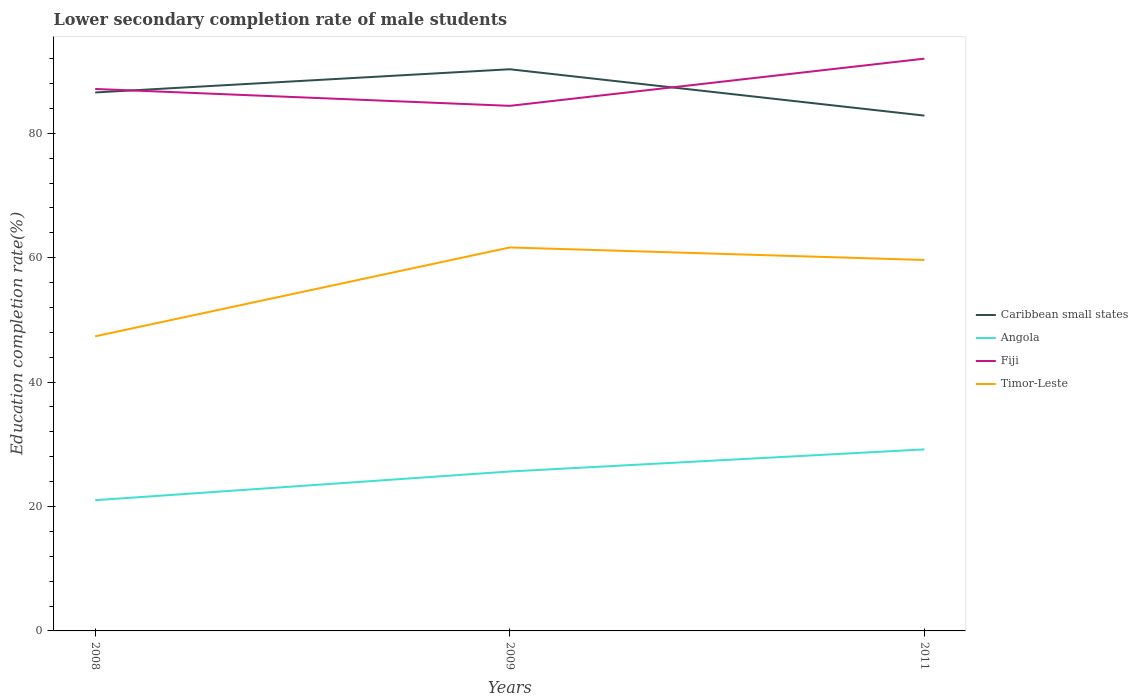How many different coloured lines are there?
Your response must be concise. 4. Does the line corresponding to Angola intersect with the line corresponding to Fiji?
Give a very brief answer. No. Is the number of lines equal to the number of legend labels?
Provide a succinct answer. Yes. Across all years, what is the maximum lower secondary completion rate of male students in Caribbean small states?
Provide a short and direct response. 82.84. What is the total lower secondary completion rate of male students in Fiji in the graph?
Give a very brief answer. 2.71. What is the difference between the highest and the second highest lower secondary completion rate of male students in Fiji?
Your response must be concise. 7.59. How many lines are there?
Keep it short and to the point. 4. What is the difference between two consecutive major ticks on the Y-axis?
Offer a terse response. 20. Does the graph contain any zero values?
Your answer should be compact. No. How are the legend labels stacked?
Ensure brevity in your answer.  Vertical. What is the title of the graph?
Offer a very short reply. Lower secondary completion rate of male students. What is the label or title of the X-axis?
Your response must be concise. Years. What is the label or title of the Y-axis?
Give a very brief answer. Education completion rate(%). What is the Education completion rate(%) in Caribbean small states in 2008?
Offer a very short reply. 86.56. What is the Education completion rate(%) in Angola in 2008?
Your answer should be very brief. 21.01. What is the Education completion rate(%) in Fiji in 2008?
Make the answer very short. 87.12. What is the Education completion rate(%) of Timor-Leste in 2008?
Offer a terse response. 47.36. What is the Education completion rate(%) of Caribbean small states in 2009?
Offer a very short reply. 90.29. What is the Education completion rate(%) in Angola in 2009?
Provide a short and direct response. 25.63. What is the Education completion rate(%) in Fiji in 2009?
Offer a very short reply. 84.41. What is the Education completion rate(%) of Timor-Leste in 2009?
Your answer should be compact. 61.64. What is the Education completion rate(%) of Caribbean small states in 2011?
Your answer should be very brief. 82.84. What is the Education completion rate(%) in Angola in 2011?
Offer a terse response. 29.18. What is the Education completion rate(%) of Fiji in 2011?
Your response must be concise. 92. What is the Education completion rate(%) in Timor-Leste in 2011?
Your response must be concise. 59.63. Across all years, what is the maximum Education completion rate(%) of Caribbean small states?
Your answer should be compact. 90.29. Across all years, what is the maximum Education completion rate(%) in Angola?
Make the answer very short. 29.18. Across all years, what is the maximum Education completion rate(%) of Fiji?
Your answer should be very brief. 92. Across all years, what is the maximum Education completion rate(%) of Timor-Leste?
Your answer should be very brief. 61.64. Across all years, what is the minimum Education completion rate(%) of Caribbean small states?
Offer a terse response. 82.84. Across all years, what is the minimum Education completion rate(%) in Angola?
Give a very brief answer. 21.01. Across all years, what is the minimum Education completion rate(%) of Fiji?
Provide a short and direct response. 84.41. Across all years, what is the minimum Education completion rate(%) of Timor-Leste?
Offer a very short reply. 47.36. What is the total Education completion rate(%) of Caribbean small states in the graph?
Your response must be concise. 259.69. What is the total Education completion rate(%) of Angola in the graph?
Your answer should be very brief. 75.83. What is the total Education completion rate(%) in Fiji in the graph?
Give a very brief answer. 263.53. What is the total Education completion rate(%) of Timor-Leste in the graph?
Offer a terse response. 168.64. What is the difference between the Education completion rate(%) of Caribbean small states in 2008 and that in 2009?
Provide a succinct answer. -3.73. What is the difference between the Education completion rate(%) in Angola in 2008 and that in 2009?
Your response must be concise. -4.62. What is the difference between the Education completion rate(%) in Fiji in 2008 and that in 2009?
Your response must be concise. 2.71. What is the difference between the Education completion rate(%) in Timor-Leste in 2008 and that in 2009?
Your answer should be very brief. -14.28. What is the difference between the Education completion rate(%) of Caribbean small states in 2008 and that in 2011?
Your answer should be very brief. 3.72. What is the difference between the Education completion rate(%) of Angola in 2008 and that in 2011?
Your answer should be compact. -8.17. What is the difference between the Education completion rate(%) of Fiji in 2008 and that in 2011?
Your response must be concise. -4.87. What is the difference between the Education completion rate(%) of Timor-Leste in 2008 and that in 2011?
Your answer should be very brief. -12.27. What is the difference between the Education completion rate(%) in Caribbean small states in 2009 and that in 2011?
Your answer should be very brief. 7.45. What is the difference between the Education completion rate(%) in Angola in 2009 and that in 2011?
Offer a very short reply. -3.55. What is the difference between the Education completion rate(%) in Fiji in 2009 and that in 2011?
Provide a short and direct response. -7.59. What is the difference between the Education completion rate(%) of Timor-Leste in 2009 and that in 2011?
Make the answer very short. 2.01. What is the difference between the Education completion rate(%) of Caribbean small states in 2008 and the Education completion rate(%) of Angola in 2009?
Your answer should be very brief. 60.93. What is the difference between the Education completion rate(%) of Caribbean small states in 2008 and the Education completion rate(%) of Fiji in 2009?
Offer a terse response. 2.15. What is the difference between the Education completion rate(%) in Caribbean small states in 2008 and the Education completion rate(%) in Timor-Leste in 2009?
Give a very brief answer. 24.92. What is the difference between the Education completion rate(%) of Angola in 2008 and the Education completion rate(%) of Fiji in 2009?
Offer a terse response. -63.4. What is the difference between the Education completion rate(%) of Angola in 2008 and the Education completion rate(%) of Timor-Leste in 2009?
Make the answer very short. -40.63. What is the difference between the Education completion rate(%) of Fiji in 2008 and the Education completion rate(%) of Timor-Leste in 2009?
Offer a terse response. 25.48. What is the difference between the Education completion rate(%) of Caribbean small states in 2008 and the Education completion rate(%) of Angola in 2011?
Ensure brevity in your answer.  57.38. What is the difference between the Education completion rate(%) of Caribbean small states in 2008 and the Education completion rate(%) of Fiji in 2011?
Your answer should be very brief. -5.43. What is the difference between the Education completion rate(%) in Caribbean small states in 2008 and the Education completion rate(%) in Timor-Leste in 2011?
Offer a terse response. 26.93. What is the difference between the Education completion rate(%) in Angola in 2008 and the Education completion rate(%) in Fiji in 2011?
Offer a very short reply. -70.98. What is the difference between the Education completion rate(%) in Angola in 2008 and the Education completion rate(%) in Timor-Leste in 2011?
Ensure brevity in your answer.  -38.62. What is the difference between the Education completion rate(%) in Fiji in 2008 and the Education completion rate(%) in Timor-Leste in 2011?
Give a very brief answer. 27.49. What is the difference between the Education completion rate(%) of Caribbean small states in 2009 and the Education completion rate(%) of Angola in 2011?
Your answer should be compact. 61.11. What is the difference between the Education completion rate(%) of Caribbean small states in 2009 and the Education completion rate(%) of Fiji in 2011?
Give a very brief answer. -1.7. What is the difference between the Education completion rate(%) in Caribbean small states in 2009 and the Education completion rate(%) in Timor-Leste in 2011?
Make the answer very short. 30.66. What is the difference between the Education completion rate(%) in Angola in 2009 and the Education completion rate(%) in Fiji in 2011?
Your answer should be very brief. -66.36. What is the difference between the Education completion rate(%) of Angola in 2009 and the Education completion rate(%) of Timor-Leste in 2011?
Provide a succinct answer. -34. What is the difference between the Education completion rate(%) in Fiji in 2009 and the Education completion rate(%) in Timor-Leste in 2011?
Offer a terse response. 24.78. What is the average Education completion rate(%) of Caribbean small states per year?
Your answer should be compact. 86.56. What is the average Education completion rate(%) in Angola per year?
Ensure brevity in your answer.  25.28. What is the average Education completion rate(%) of Fiji per year?
Your answer should be very brief. 87.84. What is the average Education completion rate(%) of Timor-Leste per year?
Offer a very short reply. 56.21. In the year 2008, what is the difference between the Education completion rate(%) in Caribbean small states and Education completion rate(%) in Angola?
Give a very brief answer. 65.55. In the year 2008, what is the difference between the Education completion rate(%) in Caribbean small states and Education completion rate(%) in Fiji?
Give a very brief answer. -0.56. In the year 2008, what is the difference between the Education completion rate(%) in Caribbean small states and Education completion rate(%) in Timor-Leste?
Offer a very short reply. 39.2. In the year 2008, what is the difference between the Education completion rate(%) in Angola and Education completion rate(%) in Fiji?
Your answer should be very brief. -66.11. In the year 2008, what is the difference between the Education completion rate(%) in Angola and Education completion rate(%) in Timor-Leste?
Make the answer very short. -26.35. In the year 2008, what is the difference between the Education completion rate(%) of Fiji and Education completion rate(%) of Timor-Leste?
Give a very brief answer. 39.76. In the year 2009, what is the difference between the Education completion rate(%) of Caribbean small states and Education completion rate(%) of Angola?
Your answer should be very brief. 64.66. In the year 2009, what is the difference between the Education completion rate(%) in Caribbean small states and Education completion rate(%) in Fiji?
Provide a succinct answer. 5.88. In the year 2009, what is the difference between the Education completion rate(%) of Caribbean small states and Education completion rate(%) of Timor-Leste?
Provide a succinct answer. 28.65. In the year 2009, what is the difference between the Education completion rate(%) of Angola and Education completion rate(%) of Fiji?
Your answer should be compact. -58.78. In the year 2009, what is the difference between the Education completion rate(%) of Angola and Education completion rate(%) of Timor-Leste?
Provide a short and direct response. -36.01. In the year 2009, what is the difference between the Education completion rate(%) in Fiji and Education completion rate(%) in Timor-Leste?
Your response must be concise. 22.76. In the year 2011, what is the difference between the Education completion rate(%) of Caribbean small states and Education completion rate(%) of Angola?
Give a very brief answer. 53.66. In the year 2011, what is the difference between the Education completion rate(%) in Caribbean small states and Education completion rate(%) in Fiji?
Your answer should be very brief. -9.15. In the year 2011, what is the difference between the Education completion rate(%) of Caribbean small states and Education completion rate(%) of Timor-Leste?
Offer a terse response. 23.21. In the year 2011, what is the difference between the Education completion rate(%) of Angola and Education completion rate(%) of Fiji?
Your answer should be compact. -62.81. In the year 2011, what is the difference between the Education completion rate(%) of Angola and Education completion rate(%) of Timor-Leste?
Offer a terse response. -30.45. In the year 2011, what is the difference between the Education completion rate(%) in Fiji and Education completion rate(%) in Timor-Leste?
Your answer should be compact. 32.36. What is the ratio of the Education completion rate(%) of Caribbean small states in 2008 to that in 2009?
Offer a terse response. 0.96. What is the ratio of the Education completion rate(%) of Angola in 2008 to that in 2009?
Offer a very short reply. 0.82. What is the ratio of the Education completion rate(%) in Fiji in 2008 to that in 2009?
Ensure brevity in your answer.  1.03. What is the ratio of the Education completion rate(%) of Timor-Leste in 2008 to that in 2009?
Offer a very short reply. 0.77. What is the ratio of the Education completion rate(%) in Caribbean small states in 2008 to that in 2011?
Your answer should be very brief. 1.04. What is the ratio of the Education completion rate(%) in Angola in 2008 to that in 2011?
Offer a very short reply. 0.72. What is the ratio of the Education completion rate(%) of Fiji in 2008 to that in 2011?
Give a very brief answer. 0.95. What is the ratio of the Education completion rate(%) of Timor-Leste in 2008 to that in 2011?
Make the answer very short. 0.79. What is the ratio of the Education completion rate(%) of Caribbean small states in 2009 to that in 2011?
Provide a short and direct response. 1.09. What is the ratio of the Education completion rate(%) in Angola in 2009 to that in 2011?
Provide a short and direct response. 0.88. What is the ratio of the Education completion rate(%) in Fiji in 2009 to that in 2011?
Make the answer very short. 0.92. What is the ratio of the Education completion rate(%) of Timor-Leste in 2009 to that in 2011?
Your answer should be very brief. 1.03. What is the difference between the highest and the second highest Education completion rate(%) of Caribbean small states?
Ensure brevity in your answer.  3.73. What is the difference between the highest and the second highest Education completion rate(%) of Angola?
Your answer should be very brief. 3.55. What is the difference between the highest and the second highest Education completion rate(%) of Fiji?
Keep it short and to the point. 4.87. What is the difference between the highest and the second highest Education completion rate(%) of Timor-Leste?
Ensure brevity in your answer.  2.01. What is the difference between the highest and the lowest Education completion rate(%) in Caribbean small states?
Ensure brevity in your answer.  7.45. What is the difference between the highest and the lowest Education completion rate(%) of Angola?
Your answer should be very brief. 8.17. What is the difference between the highest and the lowest Education completion rate(%) of Fiji?
Offer a terse response. 7.59. What is the difference between the highest and the lowest Education completion rate(%) in Timor-Leste?
Give a very brief answer. 14.28. 